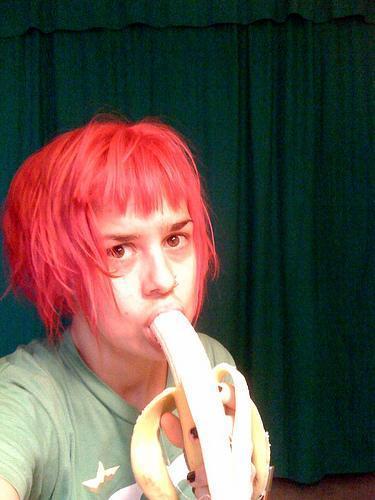How many people are in the picture?
Give a very brief answer. 1. How many people are pictured?
Give a very brief answer. 1. 